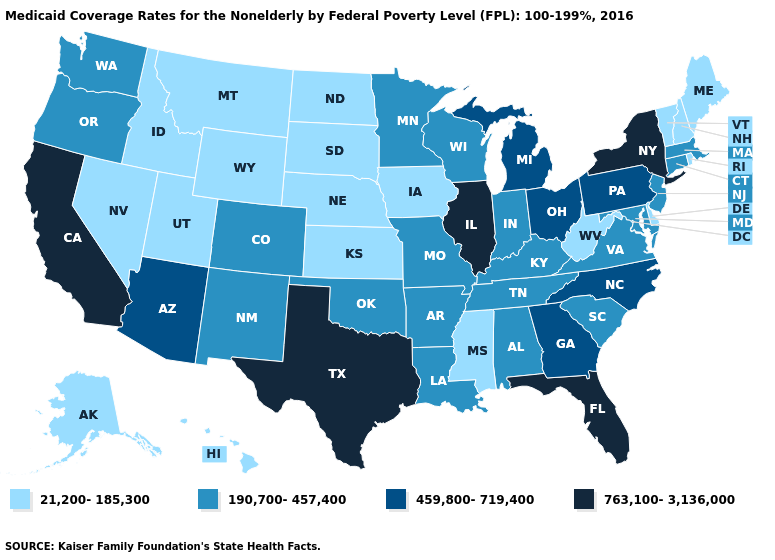What is the value of Vermont?
Give a very brief answer. 21,200-185,300. What is the value of Nebraska?
Short answer required. 21,200-185,300. Does Texas have the highest value in the South?
Give a very brief answer. Yes. Does New Mexico have the lowest value in the West?
Give a very brief answer. No. Which states have the highest value in the USA?
Be succinct. California, Florida, Illinois, New York, Texas. Name the states that have a value in the range 21,200-185,300?
Keep it brief. Alaska, Delaware, Hawaii, Idaho, Iowa, Kansas, Maine, Mississippi, Montana, Nebraska, Nevada, New Hampshire, North Dakota, Rhode Island, South Dakota, Utah, Vermont, West Virginia, Wyoming. Does Idaho have the lowest value in the USA?
Write a very short answer. Yes. Among the states that border Rhode Island , which have the highest value?
Quick response, please. Connecticut, Massachusetts. Among the states that border Louisiana , which have the lowest value?
Keep it brief. Mississippi. Does Florida have the highest value in the USA?
Keep it brief. Yes. Does California have the lowest value in the West?
Be succinct. No. Which states hav the highest value in the South?
Be succinct. Florida, Texas. Does the first symbol in the legend represent the smallest category?
Keep it brief. Yes. Among the states that border Minnesota , which have the highest value?
Write a very short answer. Wisconsin. Among the states that border California , which have the highest value?
Concise answer only. Arizona. 